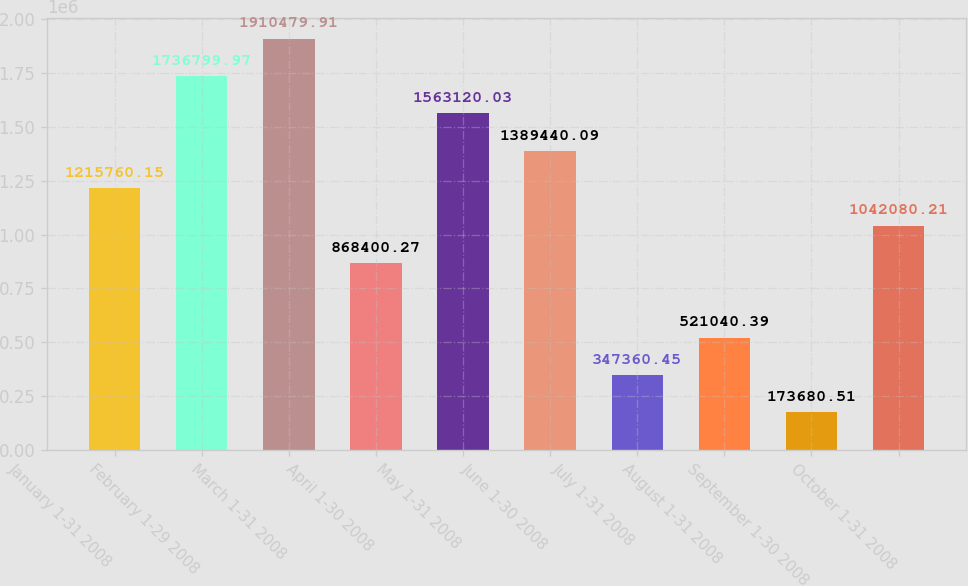Convert chart. <chart><loc_0><loc_0><loc_500><loc_500><bar_chart><fcel>January 1-31 2008<fcel>February 1-29 2008<fcel>March 1-31 2008<fcel>April 1-30 2008<fcel>May 1-31 2008<fcel>June 1-30 2008<fcel>July 1-31 2008<fcel>August 1-31 2008<fcel>September 1-30 2008<fcel>October 1-31 2008<nl><fcel>1.21576e+06<fcel>1.7368e+06<fcel>1.91048e+06<fcel>868400<fcel>1.56312e+06<fcel>1.38944e+06<fcel>347360<fcel>521040<fcel>173681<fcel>1.04208e+06<nl></chart> 